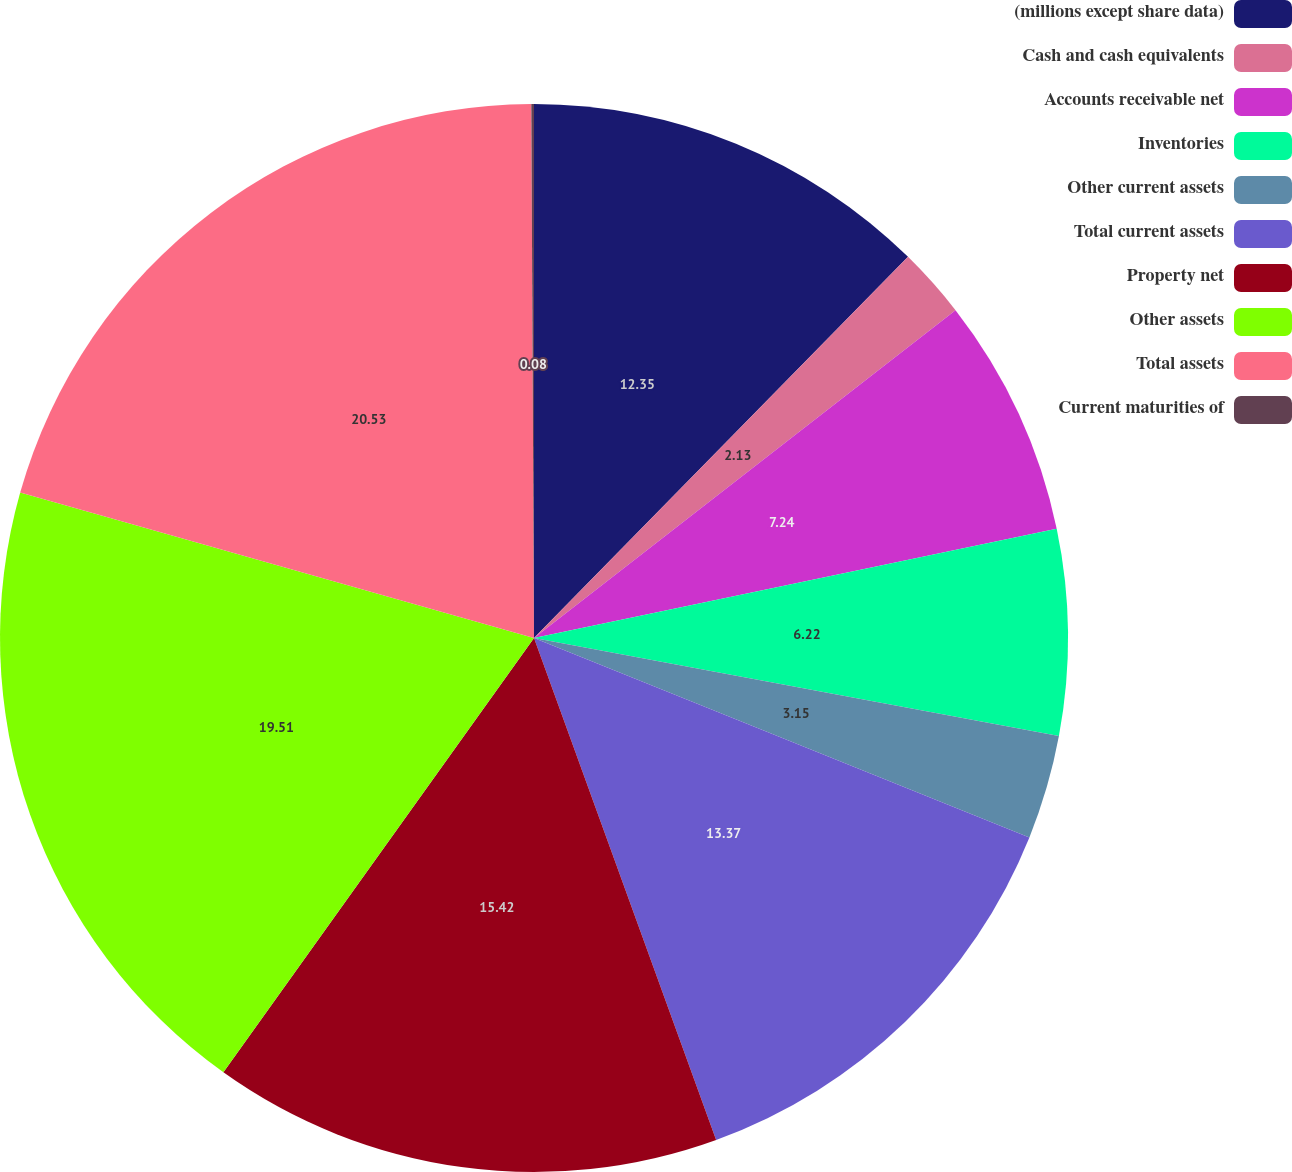Convert chart. <chart><loc_0><loc_0><loc_500><loc_500><pie_chart><fcel>(millions except share data)<fcel>Cash and cash equivalents<fcel>Accounts receivable net<fcel>Inventories<fcel>Other current assets<fcel>Total current assets<fcel>Property net<fcel>Other assets<fcel>Total assets<fcel>Current maturities of<nl><fcel>12.35%<fcel>2.13%<fcel>7.24%<fcel>6.22%<fcel>3.15%<fcel>13.37%<fcel>15.42%<fcel>19.51%<fcel>20.53%<fcel>0.08%<nl></chart> 